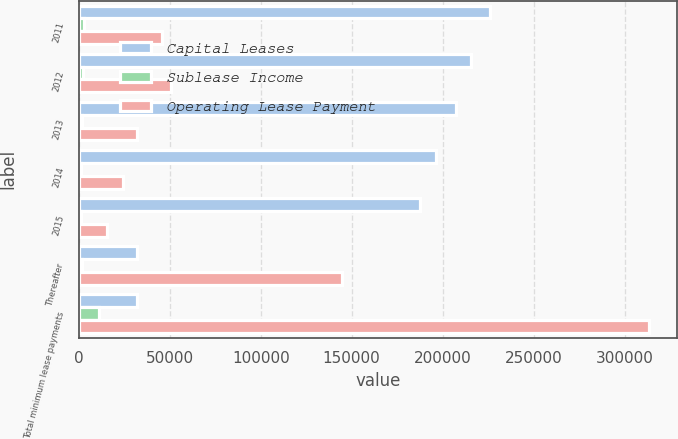Convert chart. <chart><loc_0><loc_0><loc_500><loc_500><stacked_bar_chart><ecel><fcel>2011<fcel>2012<fcel>2013<fcel>2014<fcel>2015<fcel>Thereafter<fcel>Total minimum lease payments<nl><fcel>Capital Leases<fcel>226320<fcel>215812<fcel>207556<fcel>196141<fcel>187767<fcel>32151<fcel>32151<nl><fcel>Sublease Income<fcel>2649<fcel>2042<fcel>1726<fcel>1468<fcel>1376<fcel>1899<fcel>11160<nl><fcel>Operating Lease Payment<fcel>45686<fcel>50927<fcel>32151<fcel>24281<fcel>15694<fcel>144685<fcel>313424<nl></chart> 